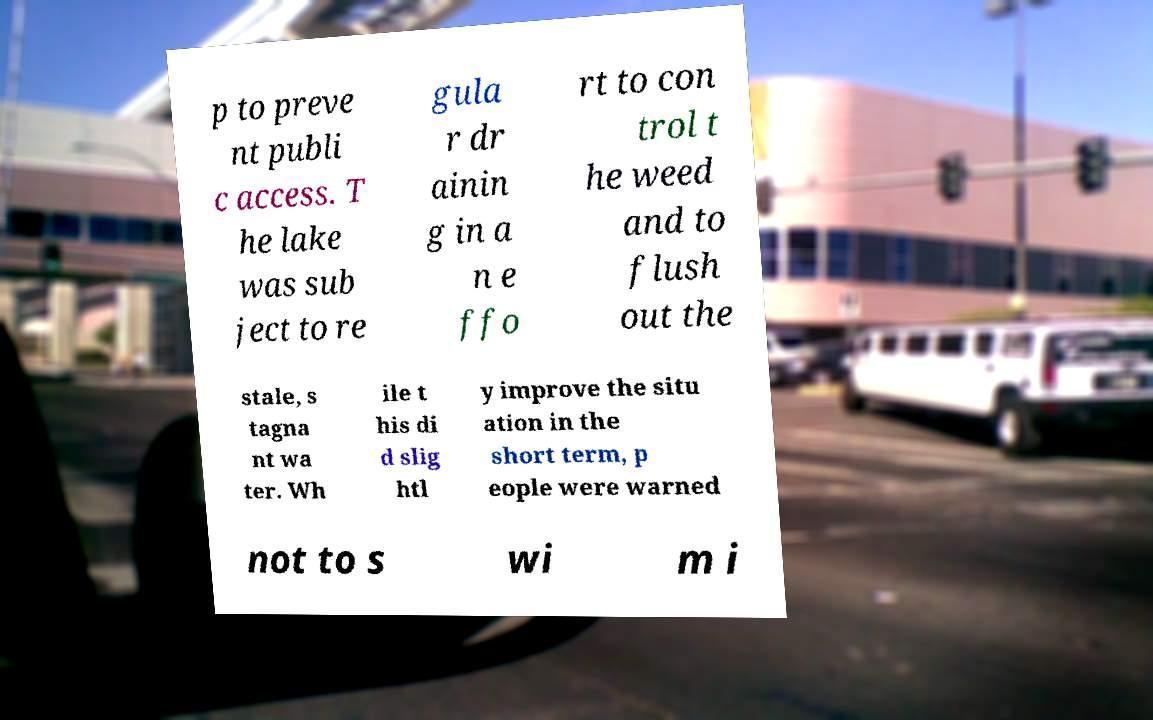Could you assist in decoding the text presented in this image and type it out clearly? p to preve nt publi c access. T he lake was sub ject to re gula r dr ainin g in a n e ffo rt to con trol t he weed and to flush out the stale, s tagna nt wa ter. Wh ile t his di d slig htl y improve the situ ation in the short term, p eople were warned not to s wi m i 